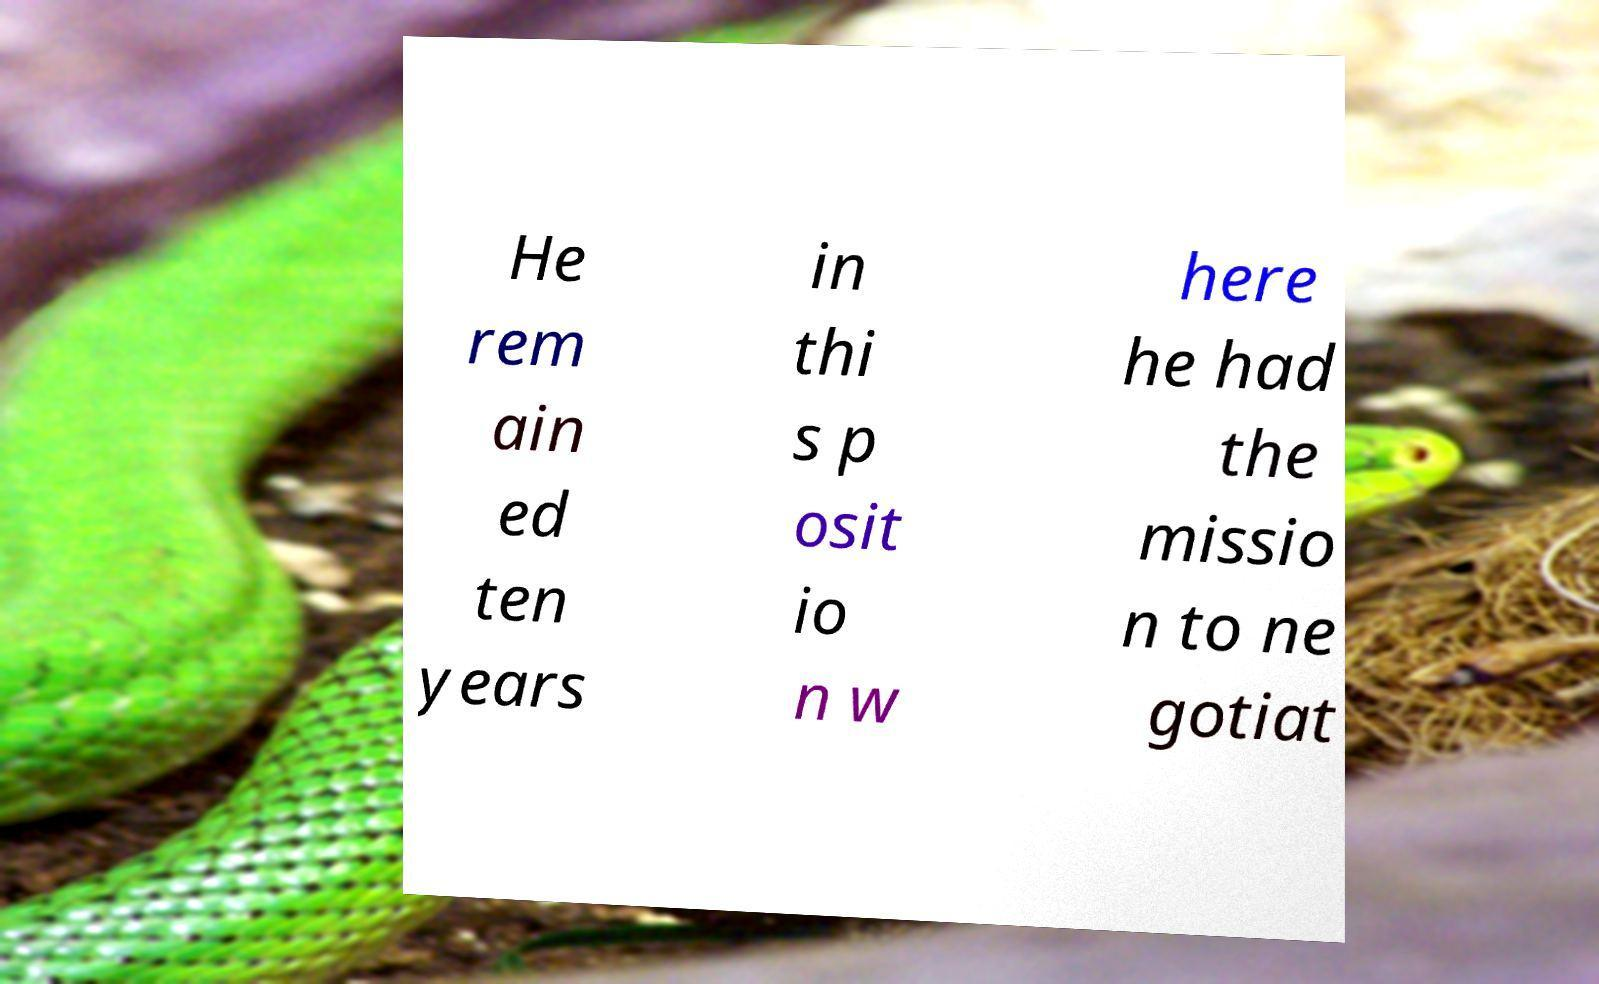Can you accurately transcribe the text from the provided image for me? He rem ain ed ten years in thi s p osit io n w here he had the missio n to ne gotiat 